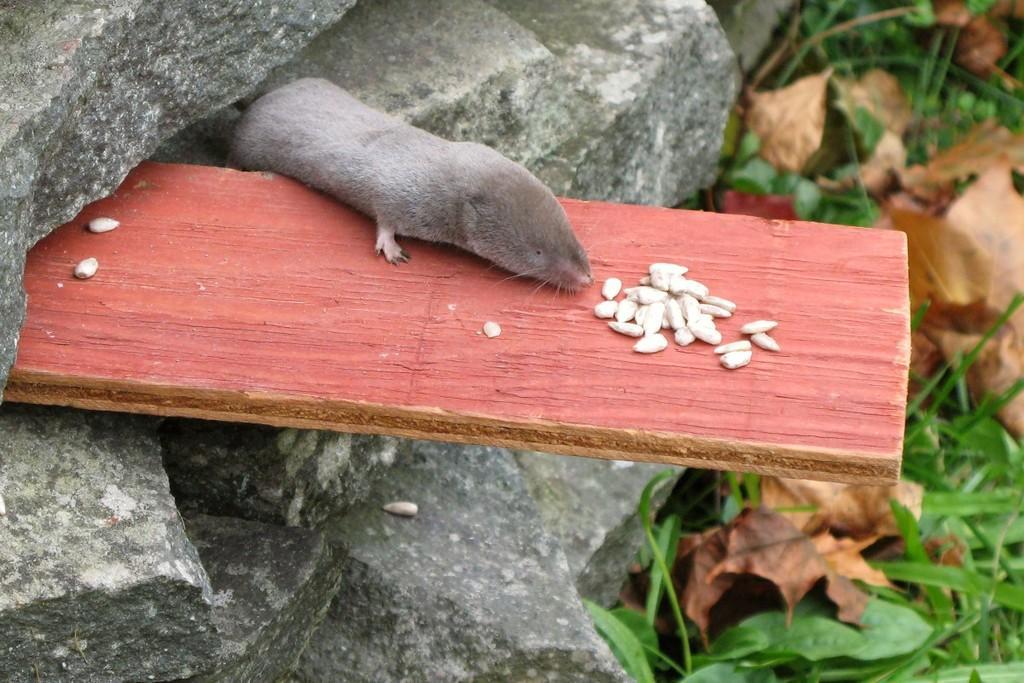Can you describe this image briefly? In the image I can see a wooden plank in between the rocks on which there is a rat which is eating something and to the there are some leaves. 